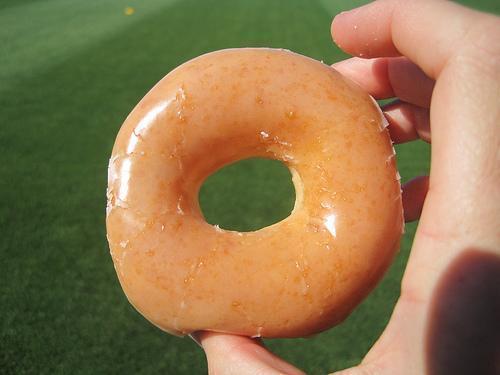How many doughnuts are there?
Give a very brief answer. 1. 